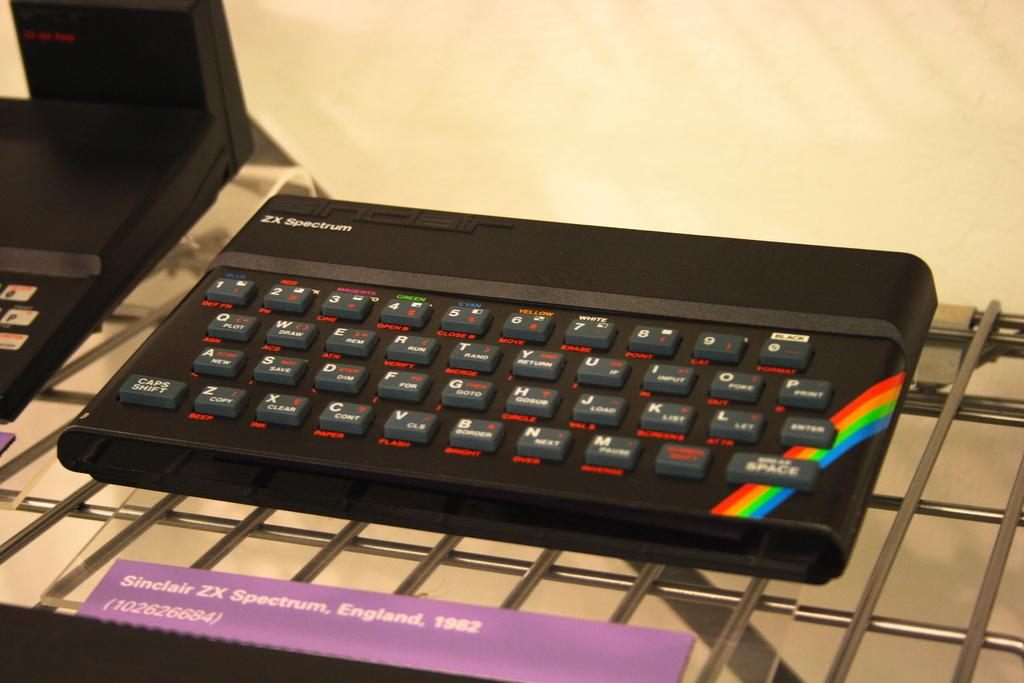<image>
Give a short and clear explanation of the subsequent image. A store display of a computer keyboard sitting on a shelf by a brand called ZX SPECTRUM. 